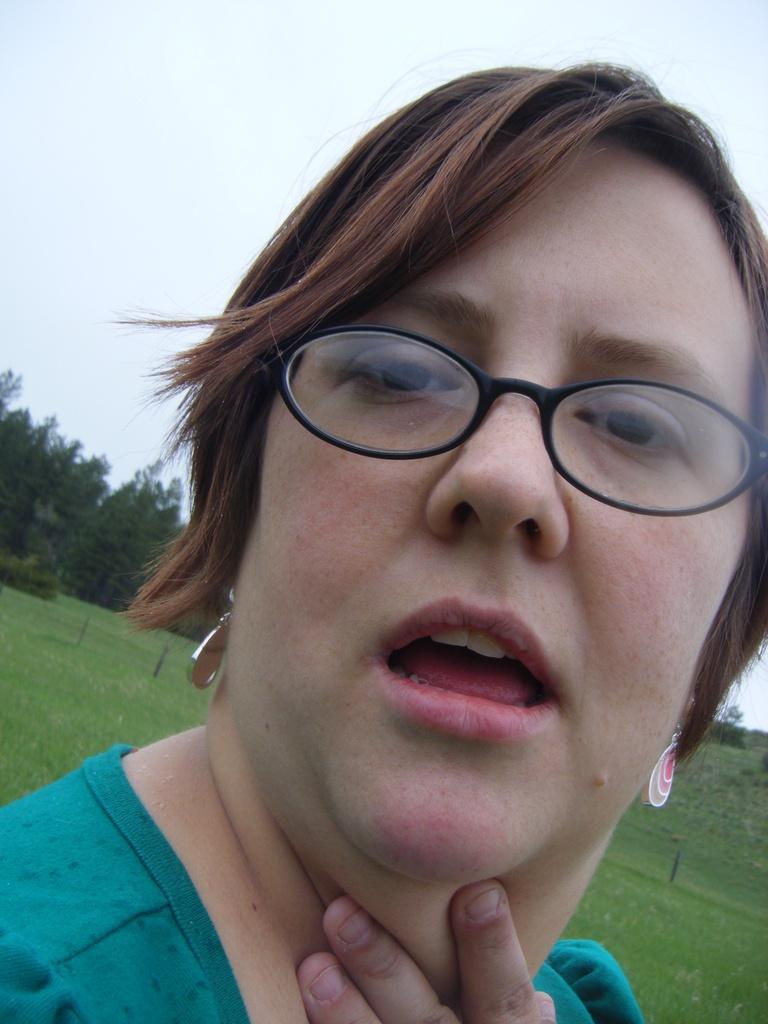Who is present in the image? There is a woman in the image. What is the woman wearing on her face? The woman is wearing spectacles. What direction is the woman looking in? The woman is looking forward. What type of vegetation can be seen in the background? There are trees and grass in the background of the image. What type of sack is the woman carrying in the image? There is no sack present in the image. Is the woman wearing a chain around her neck in the image? There is no chain visible around the woman's neck in the image. 